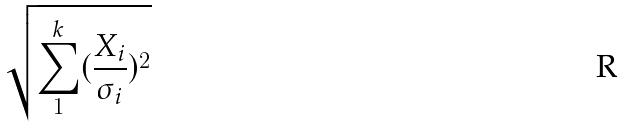Convert formula to latex. <formula><loc_0><loc_0><loc_500><loc_500>\sqrt { \sum _ { 1 } ^ { k } ( \frac { X _ { i } } { \sigma _ { i } } ) ^ { 2 } }</formula> 